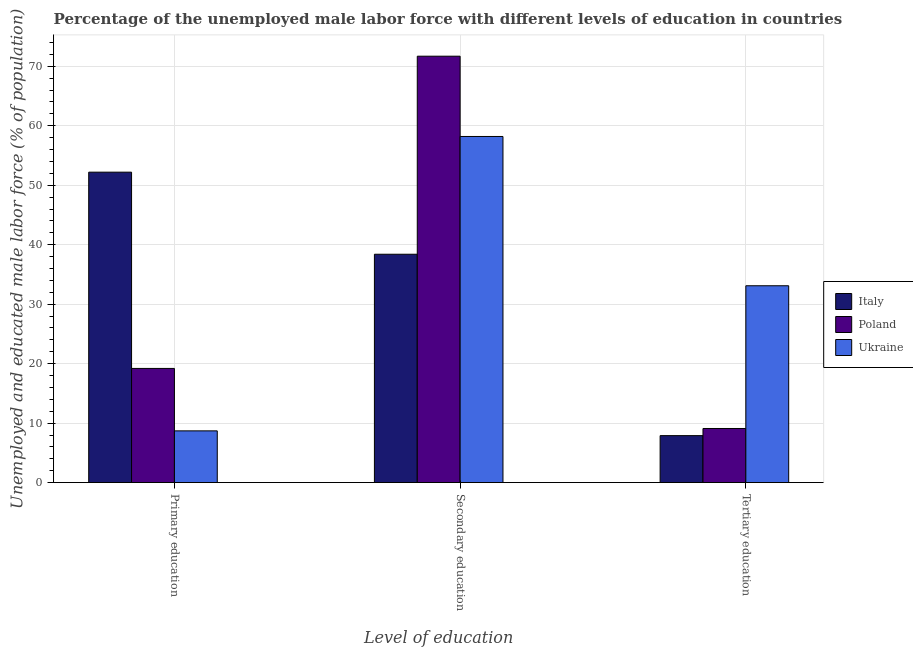How many different coloured bars are there?
Provide a short and direct response. 3. Are the number of bars on each tick of the X-axis equal?
Ensure brevity in your answer.  Yes. How many bars are there on the 3rd tick from the left?
Your response must be concise. 3. How many bars are there on the 1st tick from the right?
Your answer should be compact. 3. What is the label of the 3rd group of bars from the left?
Provide a succinct answer. Tertiary education. What is the percentage of male labor force who received secondary education in Italy?
Offer a terse response. 38.4. Across all countries, what is the maximum percentage of male labor force who received tertiary education?
Ensure brevity in your answer.  33.1. Across all countries, what is the minimum percentage of male labor force who received tertiary education?
Offer a terse response. 7.9. In which country was the percentage of male labor force who received secondary education maximum?
Your answer should be very brief. Poland. In which country was the percentage of male labor force who received primary education minimum?
Give a very brief answer. Ukraine. What is the total percentage of male labor force who received primary education in the graph?
Ensure brevity in your answer.  80.1. What is the difference between the percentage of male labor force who received tertiary education in Ukraine and that in Italy?
Provide a succinct answer. 25.2. What is the difference between the percentage of male labor force who received secondary education in Poland and the percentage of male labor force who received primary education in Ukraine?
Give a very brief answer. 63. What is the average percentage of male labor force who received tertiary education per country?
Your response must be concise. 16.7. What is the difference between the percentage of male labor force who received primary education and percentage of male labor force who received tertiary education in Poland?
Your answer should be very brief. 10.1. What is the ratio of the percentage of male labor force who received tertiary education in Italy to that in Ukraine?
Provide a succinct answer. 0.24. Is the percentage of male labor force who received secondary education in Ukraine less than that in Italy?
Offer a very short reply. No. Is the difference between the percentage of male labor force who received tertiary education in Italy and Ukraine greater than the difference between the percentage of male labor force who received secondary education in Italy and Ukraine?
Your answer should be compact. No. What is the difference between the highest and the second highest percentage of male labor force who received tertiary education?
Offer a very short reply. 24. What is the difference between the highest and the lowest percentage of male labor force who received secondary education?
Offer a very short reply. 33.3. Is the sum of the percentage of male labor force who received primary education in Poland and Italy greater than the maximum percentage of male labor force who received tertiary education across all countries?
Ensure brevity in your answer.  Yes. What does the 2nd bar from the right in Tertiary education represents?
Your answer should be very brief. Poland. How many bars are there?
Provide a succinct answer. 9. How many countries are there in the graph?
Provide a short and direct response. 3. What is the difference between two consecutive major ticks on the Y-axis?
Offer a very short reply. 10. Are the values on the major ticks of Y-axis written in scientific E-notation?
Offer a very short reply. No. Where does the legend appear in the graph?
Your answer should be very brief. Center right. How are the legend labels stacked?
Ensure brevity in your answer.  Vertical. What is the title of the graph?
Keep it short and to the point. Percentage of the unemployed male labor force with different levels of education in countries. Does "Zimbabwe" appear as one of the legend labels in the graph?
Your response must be concise. No. What is the label or title of the X-axis?
Provide a short and direct response. Level of education. What is the label or title of the Y-axis?
Offer a very short reply. Unemployed and educated male labor force (% of population). What is the Unemployed and educated male labor force (% of population) in Italy in Primary education?
Offer a terse response. 52.2. What is the Unemployed and educated male labor force (% of population) in Poland in Primary education?
Make the answer very short. 19.2. What is the Unemployed and educated male labor force (% of population) of Ukraine in Primary education?
Give a very brief answer. 8.7. What is the Unemployed and educated male labor force (% of population) of Italy in Secondary education?
Ensure brevity in your answer.  38.4. What is the Unemployed and educated male labor force (% of population) of Poland in Secondary education?
Give a very brief answer. 71.7. What is the Unemployed and educated male labor force (% of population) in Ukraine in Secondary education?
Keep it short and to the point. 58.2. What is the Unemployed and educated male labor force (% of population) of Italy in Tertiary education?
Your answer should be compact. 7.9. What is the Unemployed and educated male labor force (% of population) in Poland in Tertiary education?
Ensure brevity in your answer.  9.1. What is the Unemployed and educated male labor force (% of population) in Ukraine in Tertiary education?
Your answer should be very brief. 33.1. Across all Level of education, what is the maximum Unemployed and educated male labor force (% of population) of Italy?
Your answer should be very brief. 52.2. Across all Level of education, what is the maximum Unemployed and educated male labor force (% of population) in Poland?
Provide a short and direct response. 71.7. Across all Level of education, what is the maximum Unemployed and educated male labor force (% of population) of Ukraine?
Your answer should be compact. 58.2. Across all Level of education, what is the minimum Unemployed and educated male labor force (% of population) in Italy?
Offer a very short reply. 7.9. Across all Level of education, what is the minimum Unemployed and educated male labor force (% of population) in Poland?
Your response must be concise. 9.1. Across all Level of education, what is the minimum Unemployed and educated male labor force (% of population) in Ukraine?
Your response must be concise. 8.7. What is the total Unemployed and educated male labor force (% of population) in Italy in the graph?
Provide a succinct answer. 98.5. What is the total Unemployed and educated male labor force (% of population) in Poland in the graph?
Your answer should be very brief. 100. What is the difference between the Unemployed and educated male labor force (% of population) in Italy in Primary education and that in Secondary education?
Offer a very short reply. 13.8. What is the difference between the Unemployed and educated male labor force (% of population) of Poland in Primary education and that in Secondary education?
Ensure brevity in your answer.  -52.5. What is the difference between the Unemployed and educated male labor force (% of population) in Ukraine in Primary education and that in Secondary education?
Offer a terse response. -49.5. What is the difference between the Unemployed and educated male labor force (% of population) in Italy in Primary education and that in Tertiary education?
Provide a short and direct response. 44.3. What is the difference between the Unemployed and educated male labor force (% of population) of Ukraine in Primary education and that in Tertiary education?
Your response must be concise. -24.4. What is the difference between the Unemployed and educated male labor force (% of population) in Italy in Secondary education and that in Tertiary education?
Provide a short and direct response. 30.5. What is the difference between the Unemployed and educated male labor force (% of population) of Poland in Secondary education and that in Tertiary education?
Provide a short and direct response. 62.6. What is the difference between the Unemployed and educated male labor force (% of population) of Ukraine in Secondary education and that in Tertiary education?
Provide a succinct answer. 25.1. What is the difference between the Unemployed and educated male labor force (% of population) in Italy in Primary education and the Unemployed and educated male labor force (% of population) in Poland in Secondary education?
Your answer should be compact. -19.5. What is the difference between the Unemployed and educated male labor force (% of population) in Italy in Primary education and the Unemployed and educated male labor force (% of population) in Ukraine in Secondary education?
Keep it short and to the point. -6. What is the difference between the Unemployed and educated male labor force (% of population) of Poland in Primary education and the Unemployed and educated male labor force (% of population) of Ukraine in Secondary education?
Make the answer very short. -39. What is the difference between the Unemployed and educated male labor force (% of population) of Italy in Primary education and the Unemployed and educated male labor force (% of population) of Poland in Tertiary education?
Give a very brief answer. 43.1. What is the difference between the Unemployed and educated male labor force (% of population) in Italy in Secondary education and the Unemployed and educated male labor force (% of population) in Poland in Tertiary education?
Keep it short and to the point. 29.3. What is the difference between the Unemployed and educated male labor force (% of population) of Italy in Secondary education and the Unemployed and educated male labor force (% of population) of Ukraine in Tertiary education?
Offer a very short reply. 5.3. What is the difference between the Unemployed and educated male labor force (% of population) of Poland in Secondary education and the Unemployed and educated male labor force (% of population) of Ukraine in Tertiary education?
Offer a very short reply. 38.6. What is the average Unemployed and educated male labor force (% of population) in Italy per Level of education?
Provide a short and direct response. 32.83. What is the average Unemployed and educated male labor force (% of population) in Poland per Level of education?
Give a very brief answer. 33.33. What is the average Unemployed and educated male labor force (% of population) of Ukraine per Level of education?
Ensure brevity in your answer.  33.33. What is the difference between the Unemployed and educated male labor force (% of population) of Italy and Unemployed and educated male labor force (% of population) of Poland in Primary education?
Ensure brevity in your answer.  33. What is the difference between the Unemployed and educated male labor force (% of population) in Italy and Unemployed and educated male labor force (% of population) in Ukraine in Primary education?
Provide a succinct answer. 43.5. What is the difference between the Unemployed and educated male labor force (% of population) of Poland and Unemployed and educated male labor force (% of population) of Ukraine in Primary education?
Keep it short and to the point. 10.5. What is the difference between the Unemployed and educated male labor force (% of population) of Italy and Unemployed and educated male labor force (% of population) of Poland in Secondary education?
Offer a very short reply. -33.3. What is the difference between the Unemployed and educated male labor force (% of population) in Italy and Unemployed and educated male labor force (% of population) in Ukraine in Secondary education?
Your answer should be compact. -19.8. What is the difference between the Unemployed and educated male labor force (% of population) of Poland and Unemployed and educated male labor force (% of population) of Ukraine in Secondary education?
Your answer should be very brief. 13.5. What is the difference between the Unemployed and educated male labor force (% of population) of Italy and Unemployed and educated male labor force (% of population) of Poland in Tertiary education?
Offer a terse response. -1.2. What is the difference between the Unemployed and educated male labor force (% of population) of Italy and Unemployed and educated male labor force (% of population) of Ukraine in Tertiary education?
Give a very brief answer. -25.2. What is the difference between the Unemployed and educated male labor force (% of population) of Poland and Unemployed and educated male labor force (% of population) of Ukraine in Tertiary education?
Your response must be concise. -24. What is the ratio of the Unemployed and educated male labor force (% of population) in Italy in Primary education to that in Secondary education?
Your response must be concise. 1.36. What is the ratio of the Unemployed and educated male labor force (% of population) in Poland in Primary education to that in Secondary education?
Your answer should be very brief. 0.27. What is the ratio of the Unemployed and educated male labor force (% of population) in Ukraine in Primary education to that in Secondary education?
Offer a terse response. 0.15. What is the ratio of the Unemployed and educated male labor force (% of population) of Italy in Primary education to that in Tertiary education?
Offer a very short reply. 6.61. What is the ratio of the Unemployed and educated male labor force (% of population) in Poland in Primary education to that in Tertiary education?
Your answer should be compact. 2.11. What is the ratio of the Unemployed and educated male labor force (% of population) of Ukraine in Primary education to that in Tertiary education?
Give a very brief answer. 0.26. What is the ratio of the Unemployed and educated male labor force (% of population) of Italy in Secondary education to that in Tertiary education?
Keep it short and to the point. 4.86. What is the ratio of the Unemployed and educated male labor force (% of population) in Poland in Secondary education to that in Tertiary education?
Ensure brevity in your answer.  7.88. What is the ratio of the Unemployed and educated male labor force (% of population) in Ukraine in Secondary education to that in Tertiary education?
Offer a very short reply. 1.76. What is the difference between the highest and the second highest Unemployed and educated male labor force (% of population) of Italy?
Provide a succinct answer. 13.8. What is the difference between the highest and the second highest Unemployed and educated male labor force (% of population) in Poland?
Your answer should be compact. 52.5. What is the difference between the highest and the second highest Unemployed and educated male labor force (% of population) in Ukraine?
Offer a very short reply. 25.1. What is the difference between the highest and the lowest Unemployed and educated male labor force (% of population) of Italy?
Your answer should be very brief. 44.3. What is the difference between the highest and the lowest Unemployed and educated male labor force (% of population) of Poland?
Offer a very short reply. 62.6. What is the difference between the highest and the lowest Unemployed and educated male labor force (% of population) in Ukraine?
Make the answer very short. 49.5. 